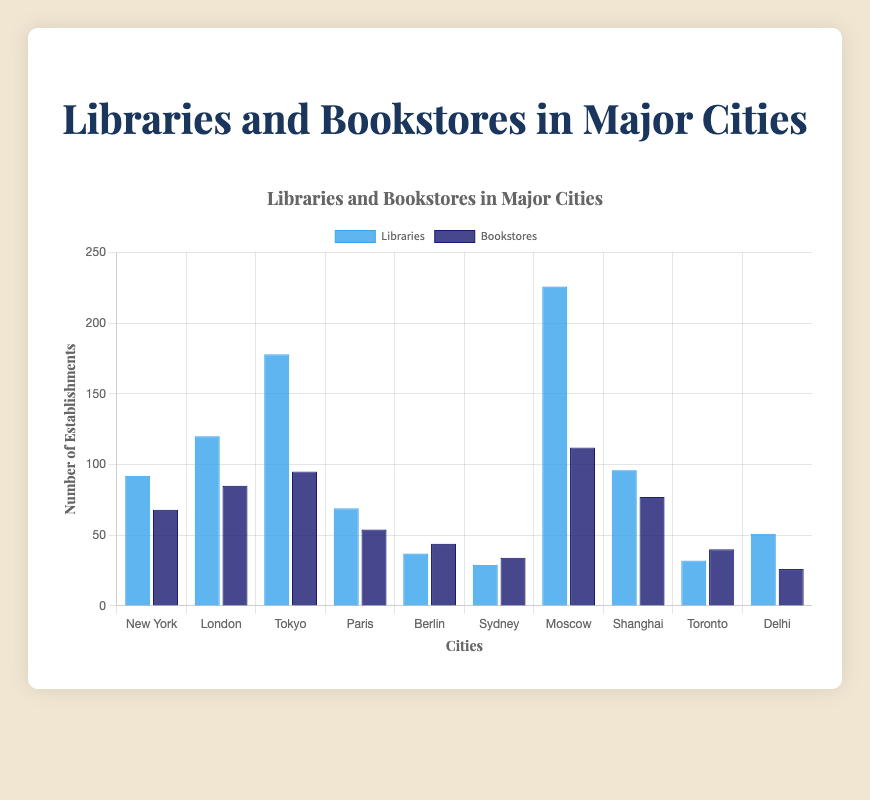Which city has the highest number of libraries? From the chart, observe the height of the bars representing libraries for each city. The tallest bar corresponds to Moscow.
Answer: Moscow Which city has more bookstores, New York or London? Compare the height of the bookstores bar for New York and London. London's bar is taller than New York's.
Answer: London What is the difference in the number of libraries between Tokyo and Berlin? Subtract the height of the library bar for Berlin from Tokyo. 178 (Tokyo) - 37 (Berlin) = 141.
Answer: 141 Which city has the lowest number of bookstores? Identify the city with the shortest bookstore bar. Delhi has the shortest bar for bookstores.
Answer: Delhi What are the total number of libraries and bookstores in Paris? Add the height of the library and bookstore bars for Paris. 69 (libraries) + 54 (bookstores) = 123.
Answer: 123 Comparing Paris and Sydney, which city has more total establishments (libraries + bookstores)? Add libraries and bookstores for both cities and compare. Paris: 69 + 54 = 123, Sydney: 29 + 34 = 63. Paris has more.
Answer: Paris What is the average number of libraries in New York, London, and Tokyo? Sum the libraries in the three cities and divide by 3. (92 + 120 + 178)/3 = 130.
Answer: 130 Which city has a greater difference between the number of libraries and bookstores, Tokyo or Moscow? Calculate the difference for each city: Tokyo: 178 - 95 = 83, Moscow: 226 - 112 = 114. Moscow has a greater difference.
Answer: Moscow What is the median number of bookstores among all cities? List the bookstores in ascending order: 26, 34, 40, 44, 54, 68, 77, 85, 95, 112. The median is the middle value which is the average of the fifth and sixth values: (54 + 68)/2 = 61.
Answer: 61 